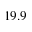Convert formula to latex. <formula><loc_0><loc_0><loc_500><loc_500>1 9 . 9</formula> 